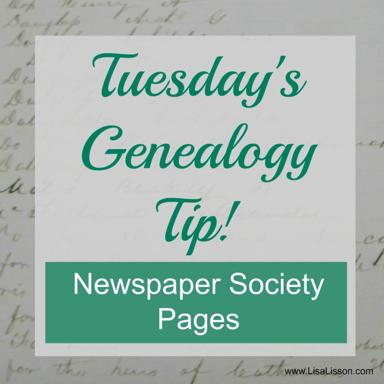How can society pages in newspapers be useful for genealogical research? Society pages in newspapers are invaluable for genealogical research as they often contain detailed announcements related to engagements, weddings, anniversaries, and other social events, providing clues about relationships, dates, and even geographical movements of families. 